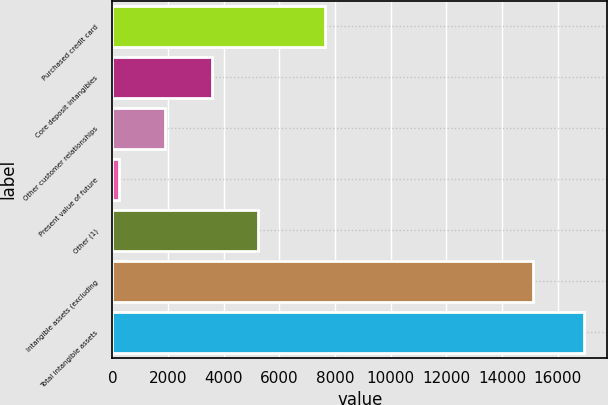Convert chart to OTSL. <chart><loc_0><loc_0><loc_500><loc_500><bar_chart><fcel>Purchased credit card<fcel>Core deposit intangibles<fcel>Other customer relationships<fcel>Present value of future<fcel>Other (1)<fcel>Intangible assets (excluding<fcel>Total intangible assets<nl><fcel>7626<fcel>3575<fcel>1904<fcel>233<fcel>5246<fcel>15098<fcel>16943<nl></chart> 